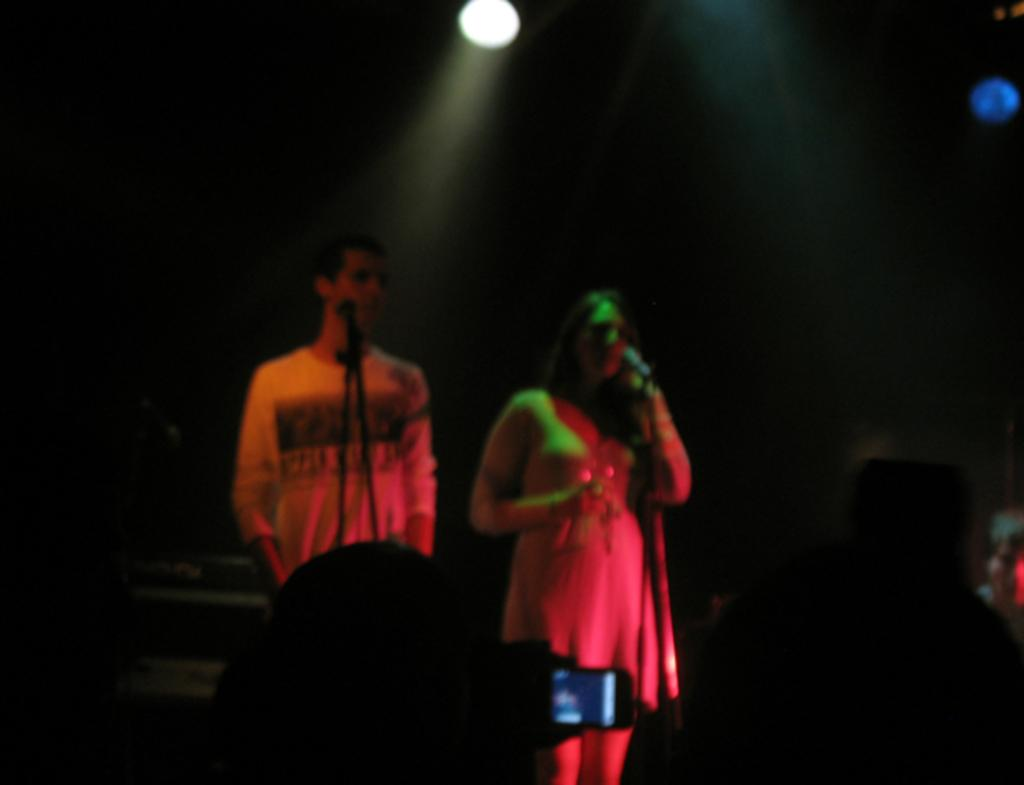What is the main feature of the image? There is focusing light in the image. Are there any people present in the image? Yes, there are people in the image. What are the people holding or using in the image? The people have microphones in front of them. How much wealth is displayed by the lettuce in the image? There is no lettuce present in the image, so it cannot be used to determine any wealth. 